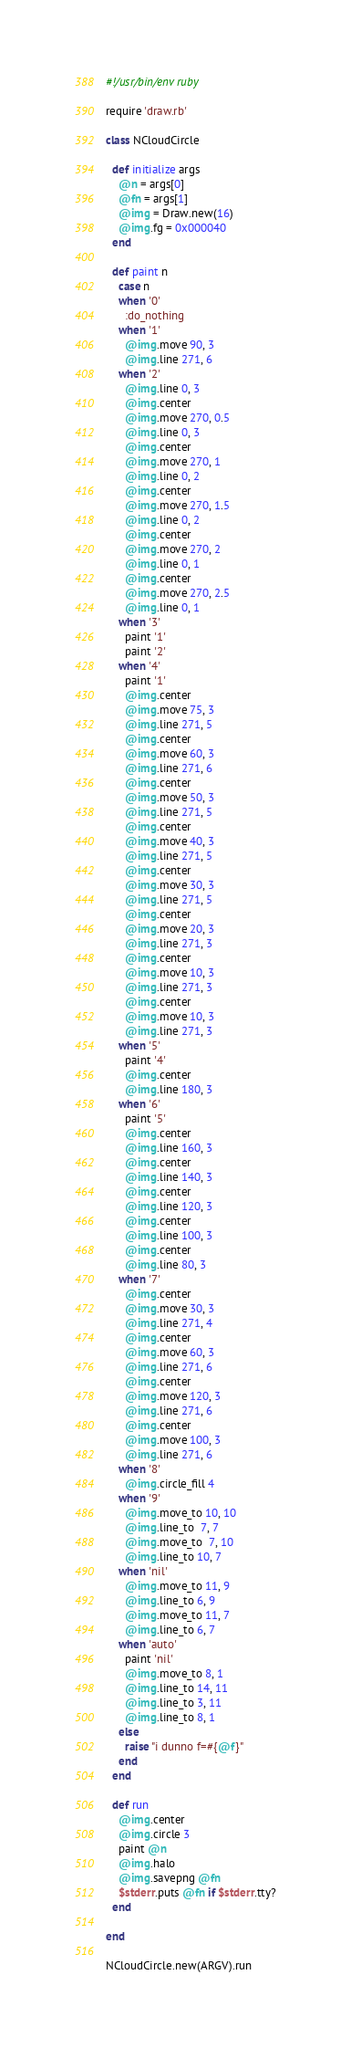Convert code to text. <code><loc_0><loc_0><loc_500><loc_500><_Ruby_>#!/usr/bin/env ruby

require 'draw.rb'

class NCloudCircle

  def initialize args
    @n = args[0]
    @fn = args[1]
    @img = Draw.new(16)
    @img.fg = 0x000040
  end

  def paint n
    case n
    when '0'
      :do_nothing
    when '1'
      @img.move 90, 3
      @img.line 271, 6
    when '2'
      @img.line 0, 3
      @img.center
      @img.move 270, 0.5
      @img.line 0, 3
      @img.center
      @img.move 270, 1
      @img.line 0, 2
      @img.center
      @img.move 270, 1.5
      @img.line 0, 2
      @img.center
      @img.move 270, 2
      @img.line 0, 1
      @img.center
      @img.move 270, 2.5
      @img.line 0, 1
    when '3'
      paint '1'
      paint '2'
    when '4'
      paint '1'
      @img.center
      @img.move 75, 3
      @img.line 271, 5
      @img.center
      @img.move 60, 3
      @img.line 271, 6
      @img.center
      @img.move 50, 3
      @img.line 271, 5
      @img.center
      @img.move 40, 3
      @img.line 271, 5
      @img.center
      @img.move 30, 3
      @img.line 271, 5
      @img.center
      @img.move 20, 3
      @img.line 271, 3
      @img.center
      @img.move 10, 3
      @img.line 271, 3
      @img.center
      @img.move 10, 3
      @img.line 271, 3
    when '5'
      paint '4'
      @img.center
      @img.line 180, 3
    when '6'
      paint '5'
      @img.center
      @img.line 160, 3
      @img.center
      @img.line 140, 3
      @img.center
      @img.line 120, 3
      @img.center
      @img.line 100, 3
      @img.center
      @img.line 80, 3
    when '7'
      @img.center
      @img.move 30, 3
      @img.line 271, 4
      @img.center
      @img.move 60, 3
      @img.line 271, 6
      @img.center
      @img.move 120, 3
      @img.line 271, 6
      @img.center
      @img.move 100, 3
      @img.line 271, 6
    when '8'
      @img.circle_fill 4
    when '9'
      @img.move_to 10, 10
      @img.line_to  7, 7
      @img.move_to  7, 10
      @img.line_to 10, 7
    when 'nil'
      @img.move_to 11, 9
      @img.line_to 6, 9
      @img.move_to 11, 7
      @img.line_to 6, 7
    when 'auto'
      paint 'nil'
      @img.move_to 8, 1
      @img.line_to 14, 11
      @img.line_to 3, 11
      @img.line_to 8, 1
    else
      raise "i dunno f=#{@f}"
    end
  end

  def run
    @img.center
    @img.circle 3
    paint @n
    @img.halo
    @img.savepng @fn
    $stderr.puts @fn if $stderr.tty?
  end

end

NCloudCircle.new(ARGV).run
</code> 